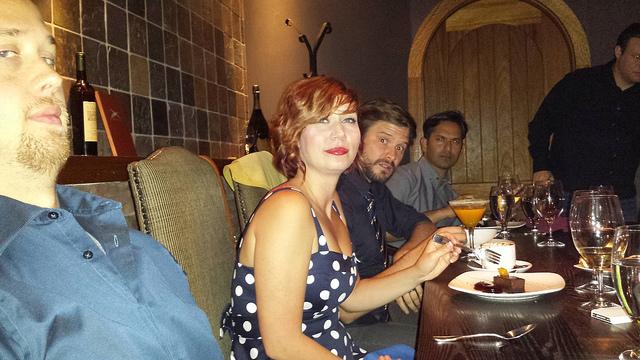What color hair is this woman sporting?
Concise answer only. Red. How many women are in the picture?
Short answer required. 1. What color are the dots?
Keep it brief. White. 